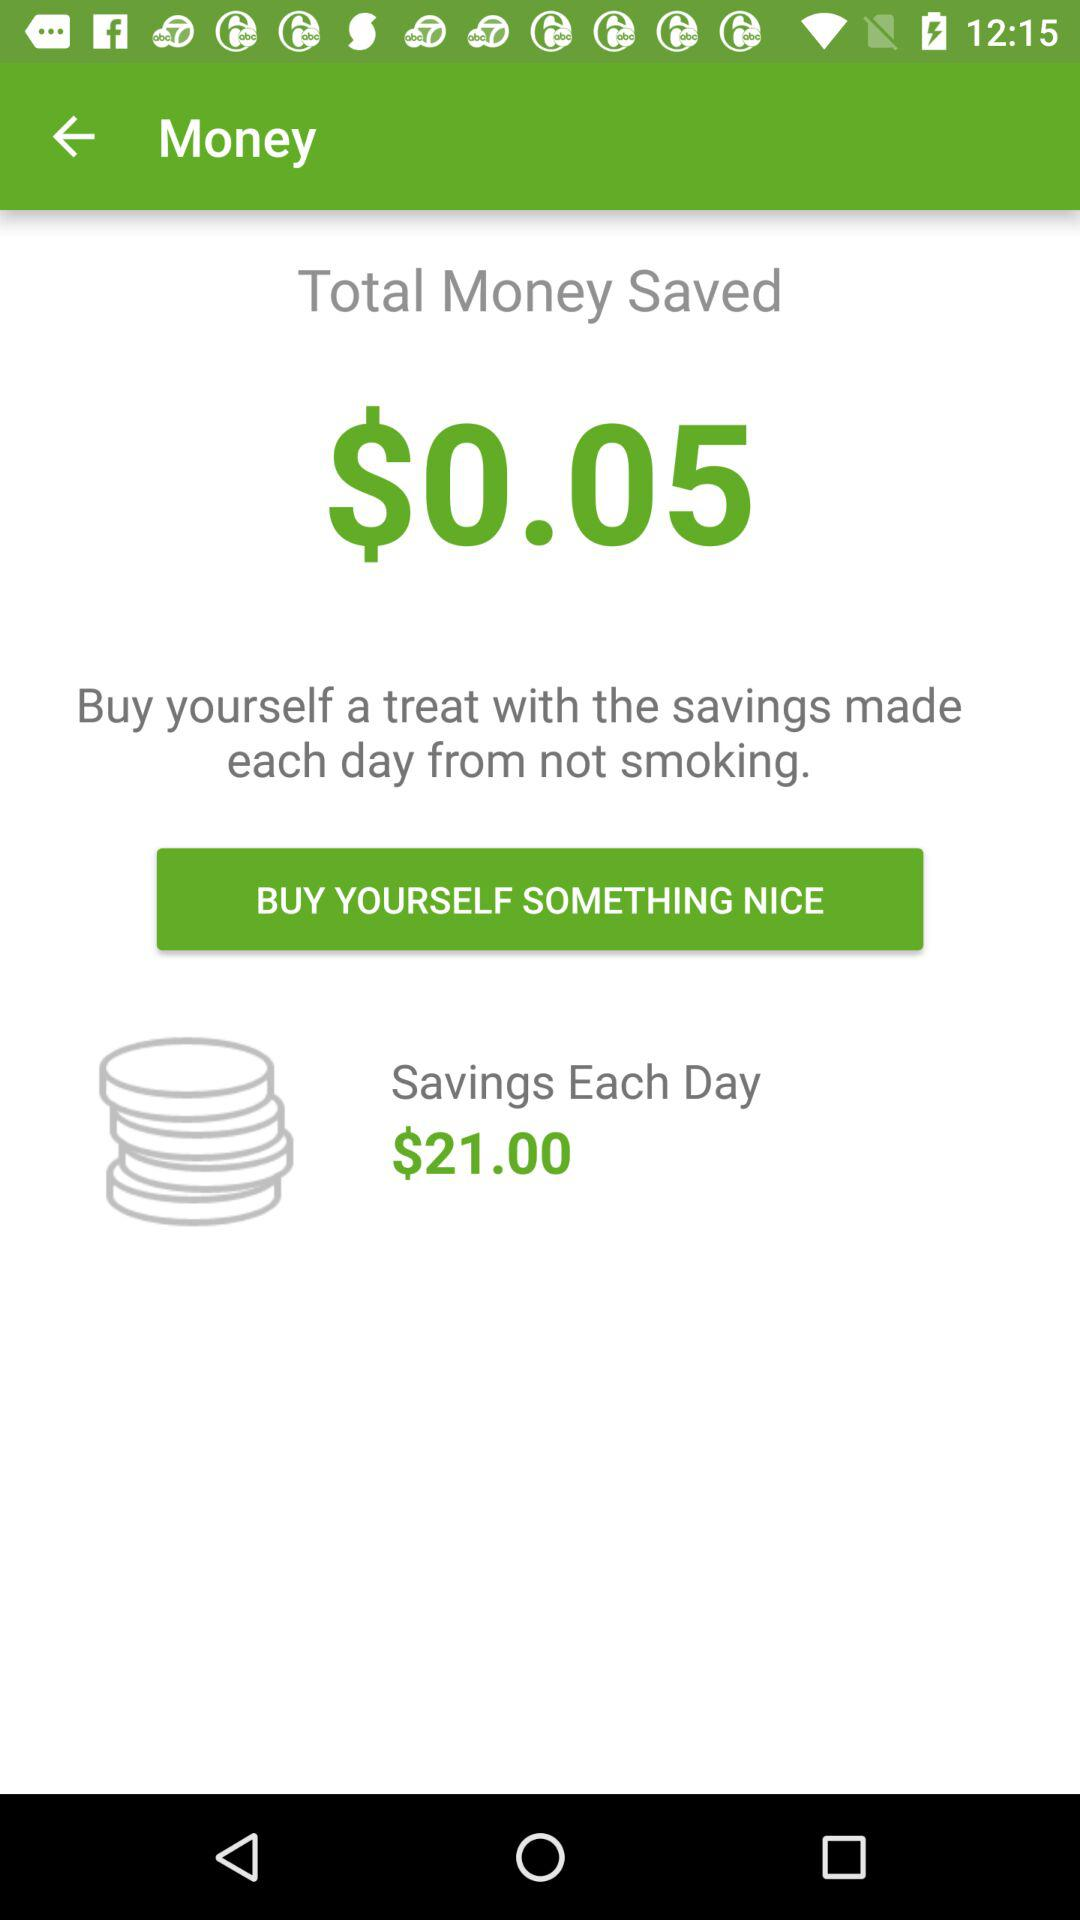How much money is saved? The saved money is $0.05. 